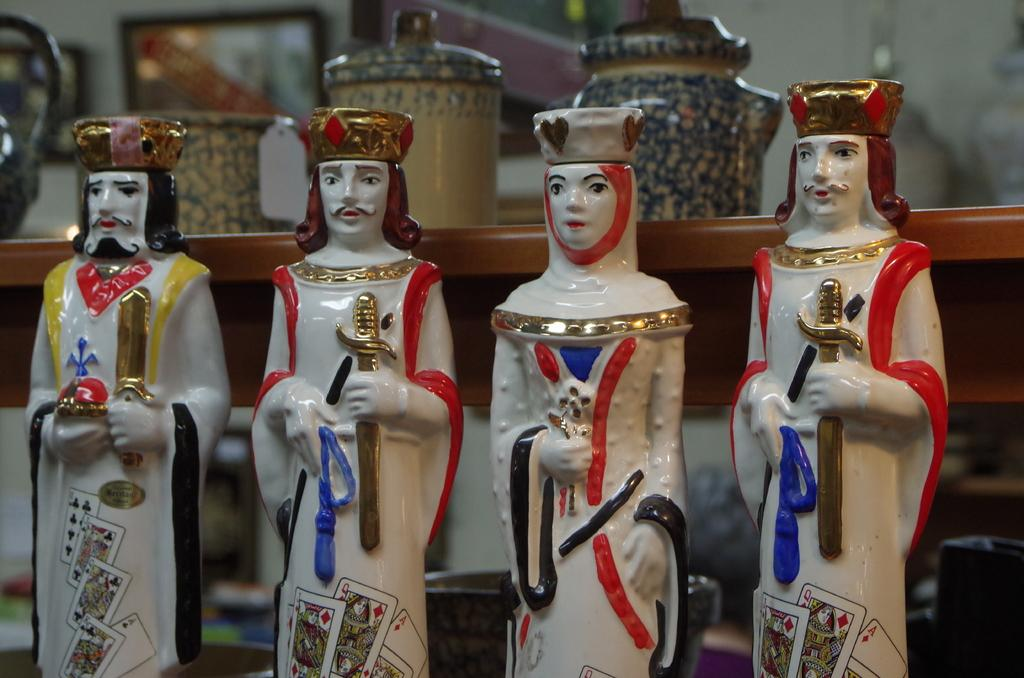What is the main subject of the image? The main subject of the image is the many idols on shelves. Can you describe the arrangement of the idols? The idols are arranged on shelves in the image. What else can be seen in the background of the image? There are jars visible behind the shelves in the image. What type of copper material is used to make the pen in the image? There is no pen present in the image, so it is not possible to determine the type of copper material used. 